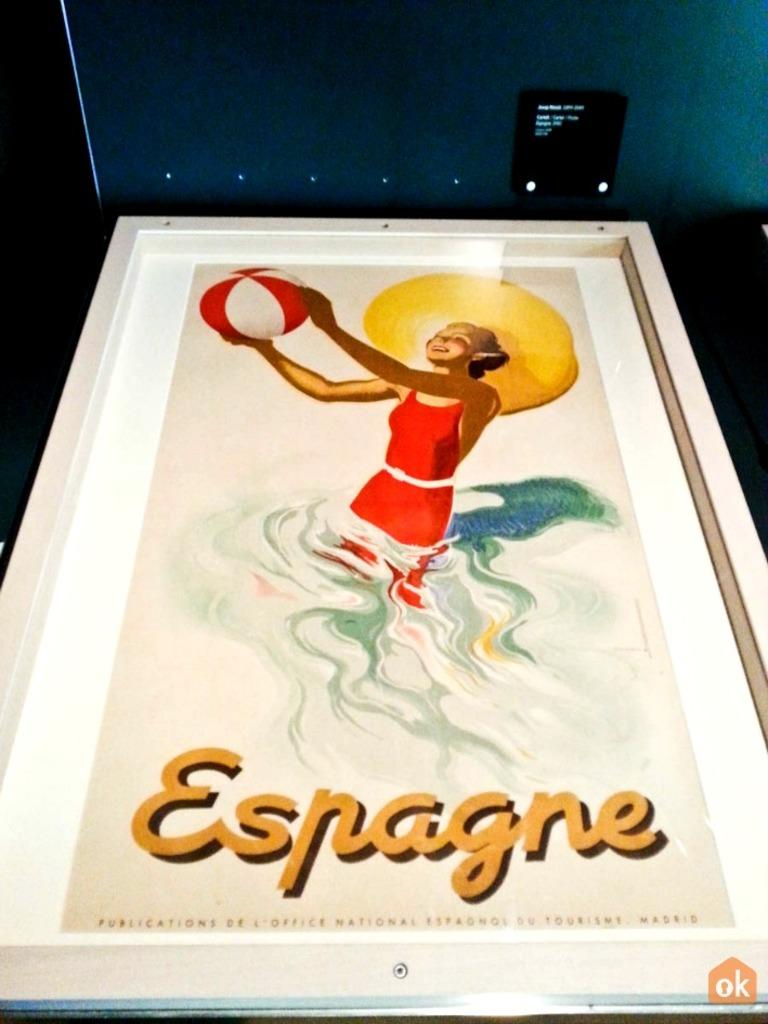What object is present in the image that contains an image within it? There is a photo frame in the image that contains a painting. What is depicted in the painting within the photo frame? The painting depicts a person smiling and holding a ball. Are there any words or text in the painting? Yes, there are texts in the painting. How would you describe the background of the painting? The background of the painting is dark in color. What type of plants can be seen growing in the brass container in the image? There are no plants or brass containers present in the image. 